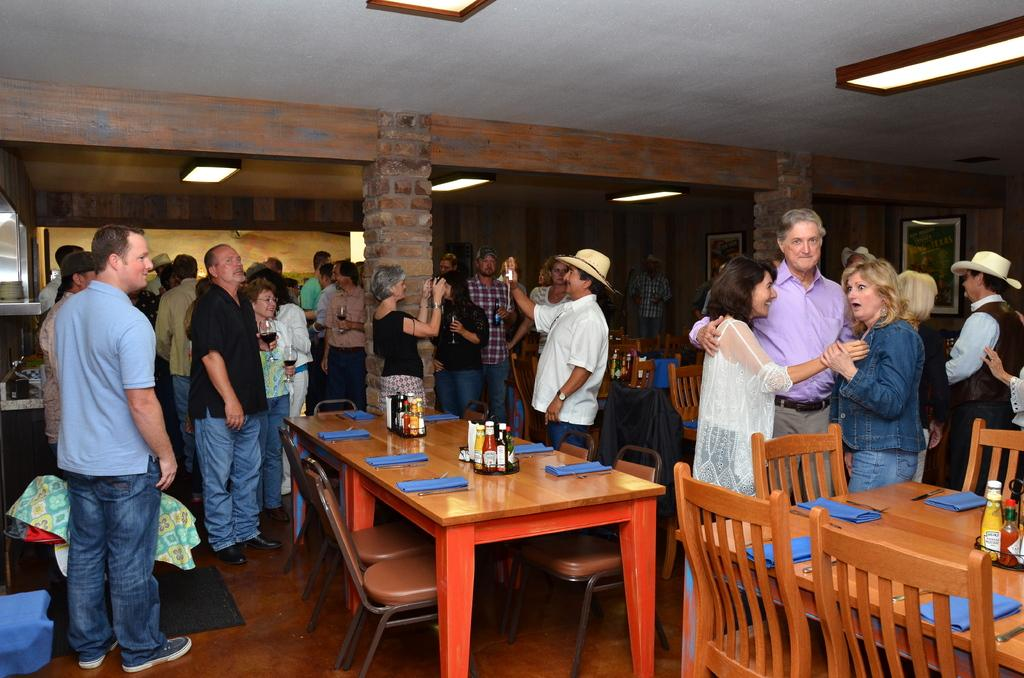What can be seen in the people doing in the image? There are people standing in the image. What type of furniture is present in the image? There are chairs and tables in the image. What is on top of the tables? There are objects on the tables. What can be seen in the background of the image? There are lights and a wall in the background of the image. What type of vacation is being enjoyed by the people in the image? There is no indication of a vacation in the image; it simply shows people standing near tables and chairs. How does the night affect the lighting in the image? The time of day is not mentioned in the image, so it cannot be determined if it is night or not. 